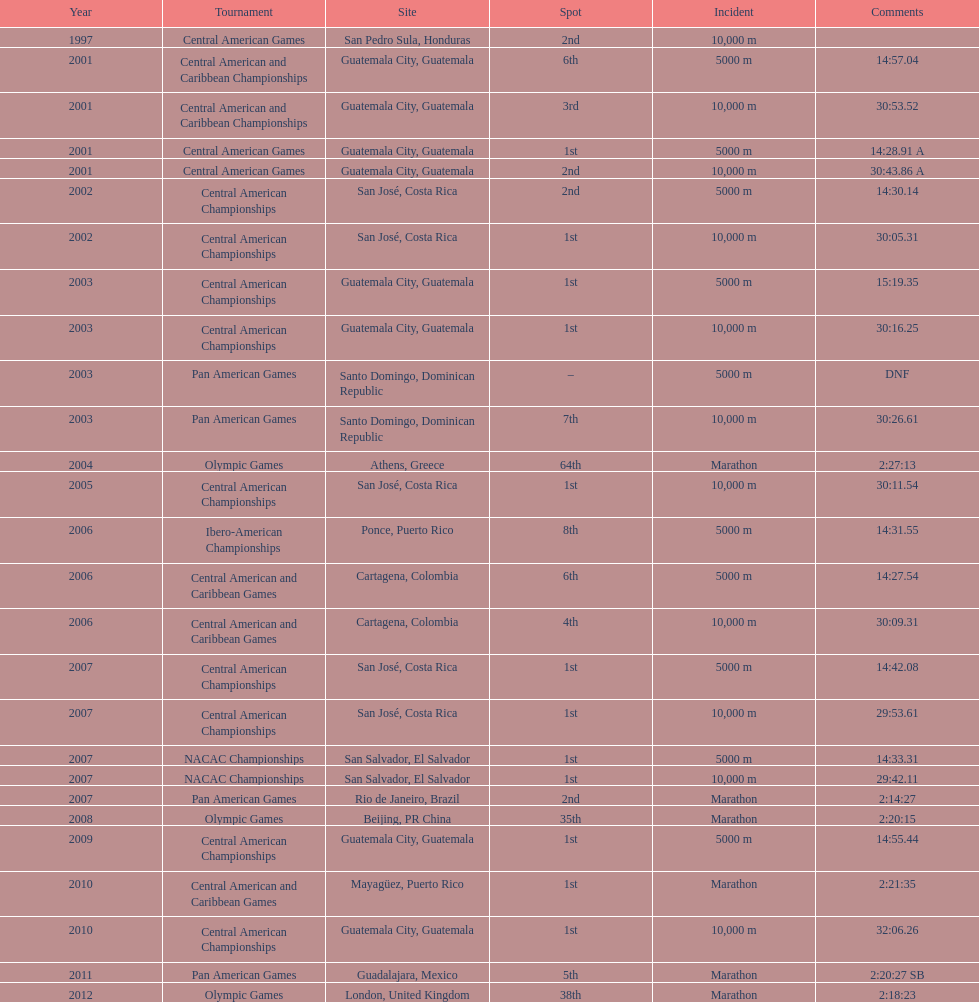What was the last competition in which a position of "2nd" was achieved? Pan American Games. 